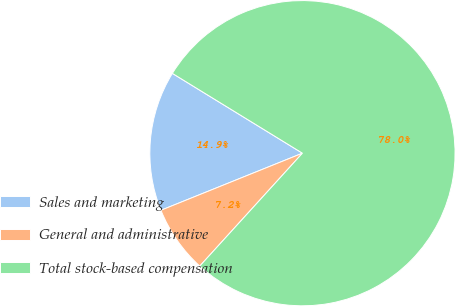Convert chart. <chart><loc_0><loc_0><loc_500><loc_500><pie_chart><fcel>Sales and marketing<fcel>General and administrative<fcel>Total stock-based compensation<nl><fcel>14.86%<fcel>7.15%<fcel>77.98%<nl></chart> 